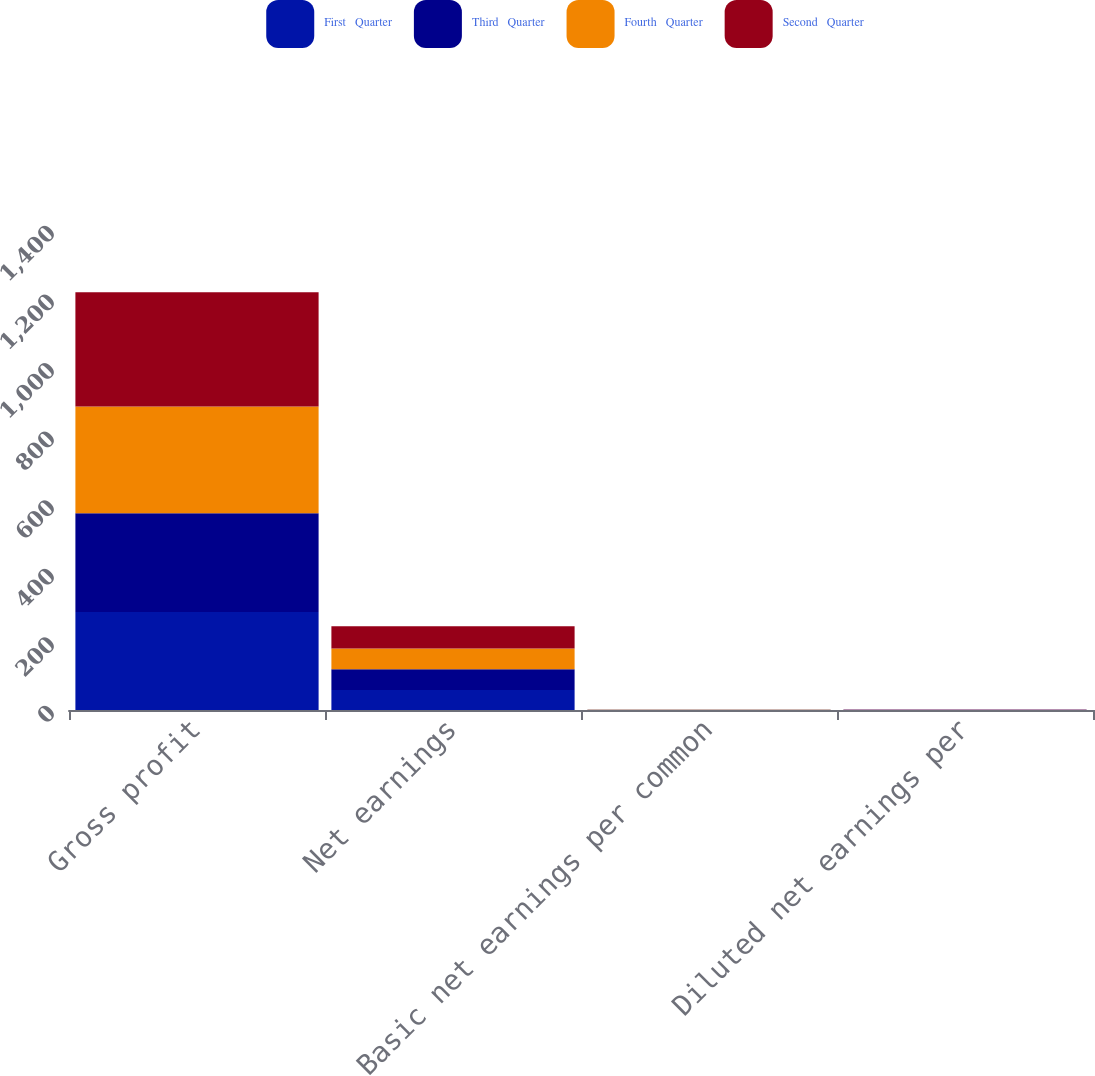Convert chart to OTSL. <chart><loc_0><loc_0><loc_500><loc_500><stacked_bar_chart><ecel><fcel>Gross profit<fcel>Net earnings<fcel>Basic net earnings per common<fcel>Diluted net earnings per<nl><fcel>First   Quarter<fcel>285.7<fcel>58.1<fcel>0.37<fcel>0.32<nl><fcel>Third   Quarter<fcel>288.1<fcel>60.5<fcel>0.38<fcel>0.33<nl><fcel>Fourth   Quarter<fcel>311.1<fcel>60.6<fcel>0.38<fcel>0.34<nl><fcel>Second   Quarter<fcel>333.6<fcel>65.1<fcel>0.41<fcel>0.37<nl></chart> 